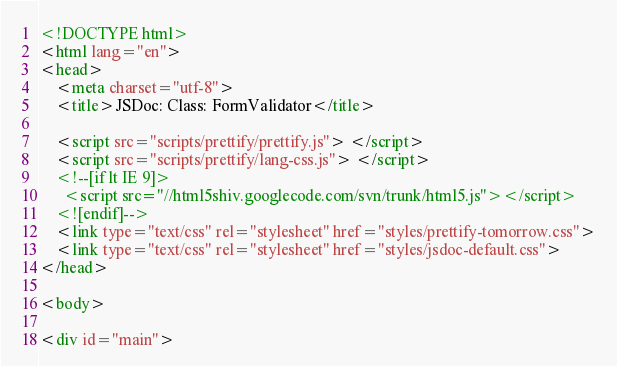Convert code to text. <code><loc_0><loc_0><loc_500><loc_500><_HTML_><!DOCTYPE html>
<html lang="en">
<head>
    <meta charset="utf-8">
    <title>JSDoc: Class: FormValidator</title>

    <script src="scripts/prettify/prettify.js"> </script>
    <script src="scripts/prettify/lang-css.js"> </script>
    <!--[if lt IE 9]>
      <script src="//html5shiv.googlecode.com/svn/trunk/html5.js"></script>
    <![endif]-->
    <link type="text/css" rel="stylesheet" href="styles/prettify-tomorrow.css">
    <link type="text/css" rel="stylesheet" href="styles/jsdoc-default.css">
</head>

<body>

<div id="main">
</code> 